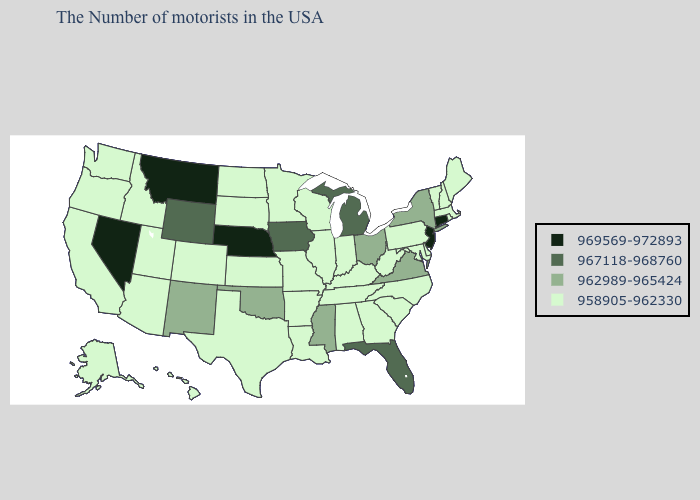Name the states that have a value in the range 967118-968760?
Give a very brief answer. Florida, Michigan, Iowa, Wyoming. What is the value of Nebraska?
Concise answer only. 969569-972893. What is the value of Arkansas?
Write a very short answer. 958905-962330. Does Nevada have the lowest value in the USA?
Short answer required. No. Does the map have missing data?
Write a very short answer. No. Does the map have missing data?
Quick response, please. No. Which states have the highest value in the USA?
Give a very brief answer. Connecticut, New Jersey, Nebraska, Montana, Nevada. Does Nevada have a higher value than New York?
Short answer required. Yes. Is the legend a continuous bar?
Concise answer only. No. Name the states that have a value in the range 969569-972893?
Be succinct. Connecticut, New Jersey, Nebraska, Montana, Nevada. What is the lowest value in the USA?
Write a very short answer. 958905-962330. What is the value of Oklahoma?
Quick response, please. 962989-965424. Does the first symbol in the legend represent the smallest category?
Write a very short answer. No. Name the states that have a value in the range 969569-972893?
Give a very brief answer. Connecticut, New Jersey, Nebraska, Montana, Nevada. What is the highest value in the MidWest ?
Be succinct. 969569-972893. 